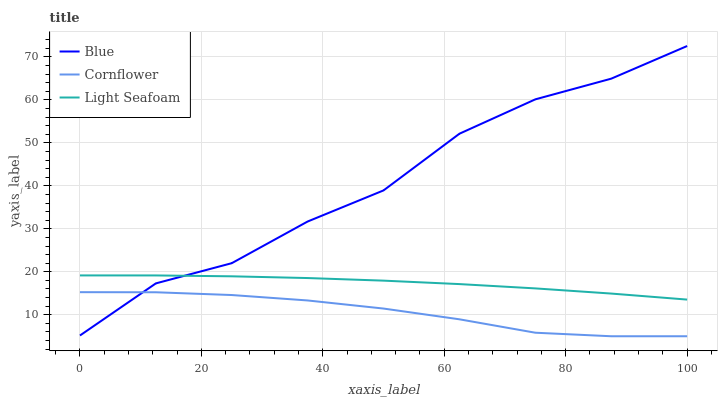Does Light Seafoam have the minimum area under the curve?
Answer yes or no. No. Does Light Seafoam have the maximum area under the curve?
Answer yes or no. No. Is Cornflower the smoothest?
Answer yes or no. No. Is Cornflower the roughest?
Answer yes or no. No. Does Light Seafoam have the lowest value?
Answer yes or no. No. Does Light Seafoam have the highest value?
Answer yes or no. No. Is Cornflower less than Light Seafoam?
Answer yes or no. Yes. Is Light Seafoam greater than Cornflower?
Answer yes or no. Yes. Does Cornflower intersect Light Seafoam?
Answer yes or no. No. 